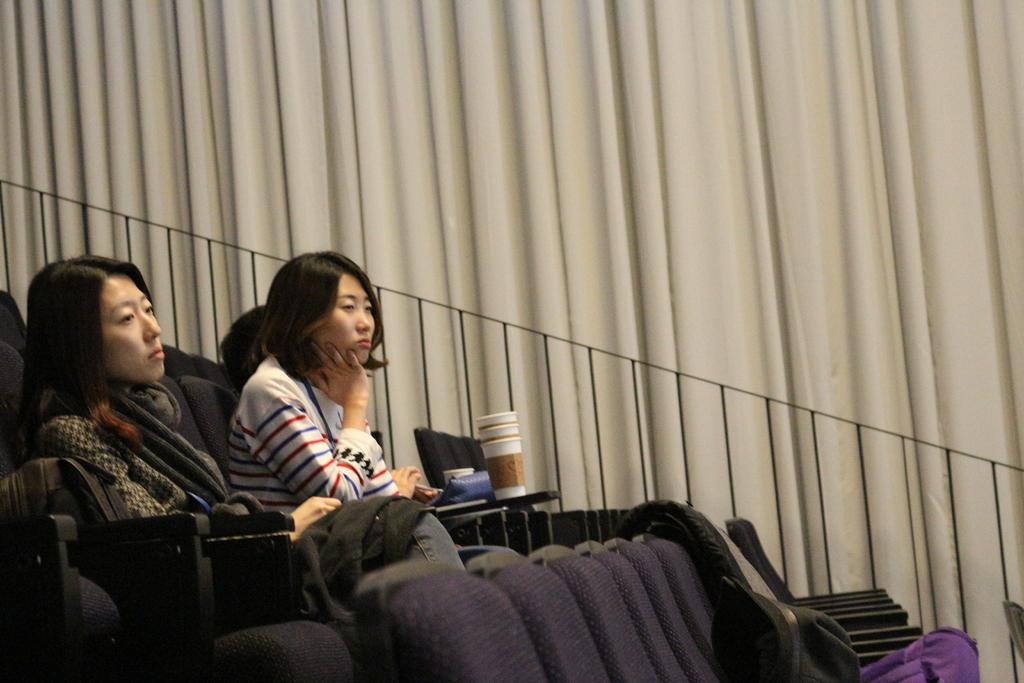What type of window treatment is visible in the image? There are curtains in the image. What are the people in the image doing? The people in the image are sitting on chairs. What objects can be seen in the image that might be used for drinking? There are glasses in the image. What type of wrist accessory is visible on the people in the image? There is no wrist accessory visible on the people in the image. Is there a rifle present in the image? No, there is no rifle present in the image. 